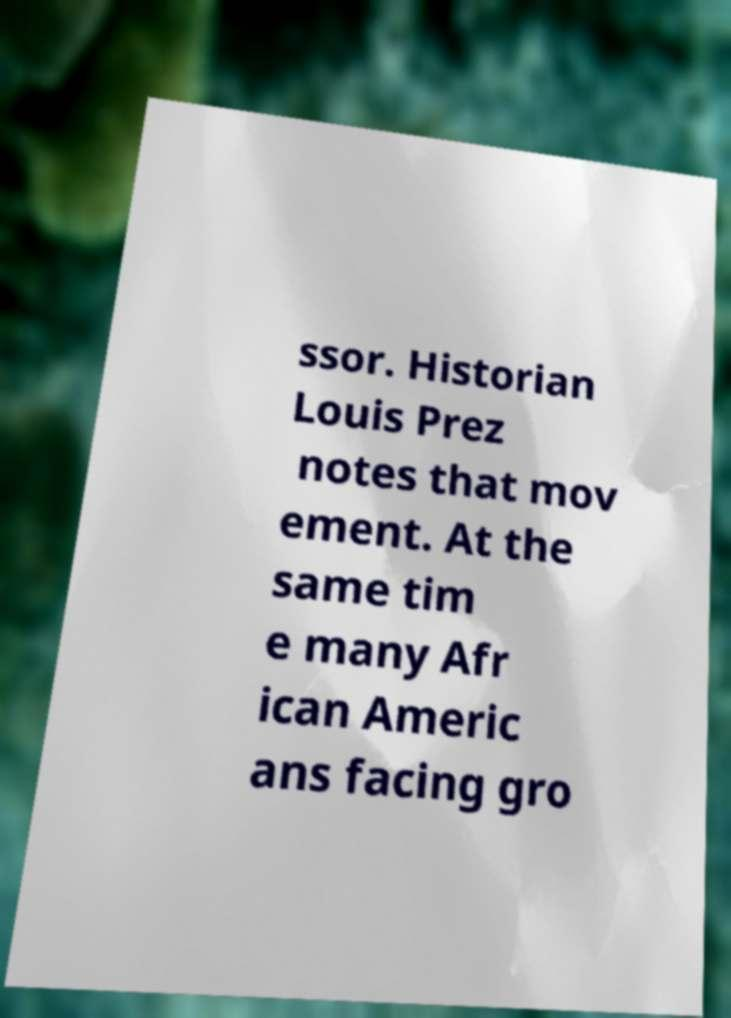I need the written content from this picture converted into text. Can you do that? ssor. Historian Louis Prez notes that mov ement. At the same tim e many Afr ican Americ ans facing gro 